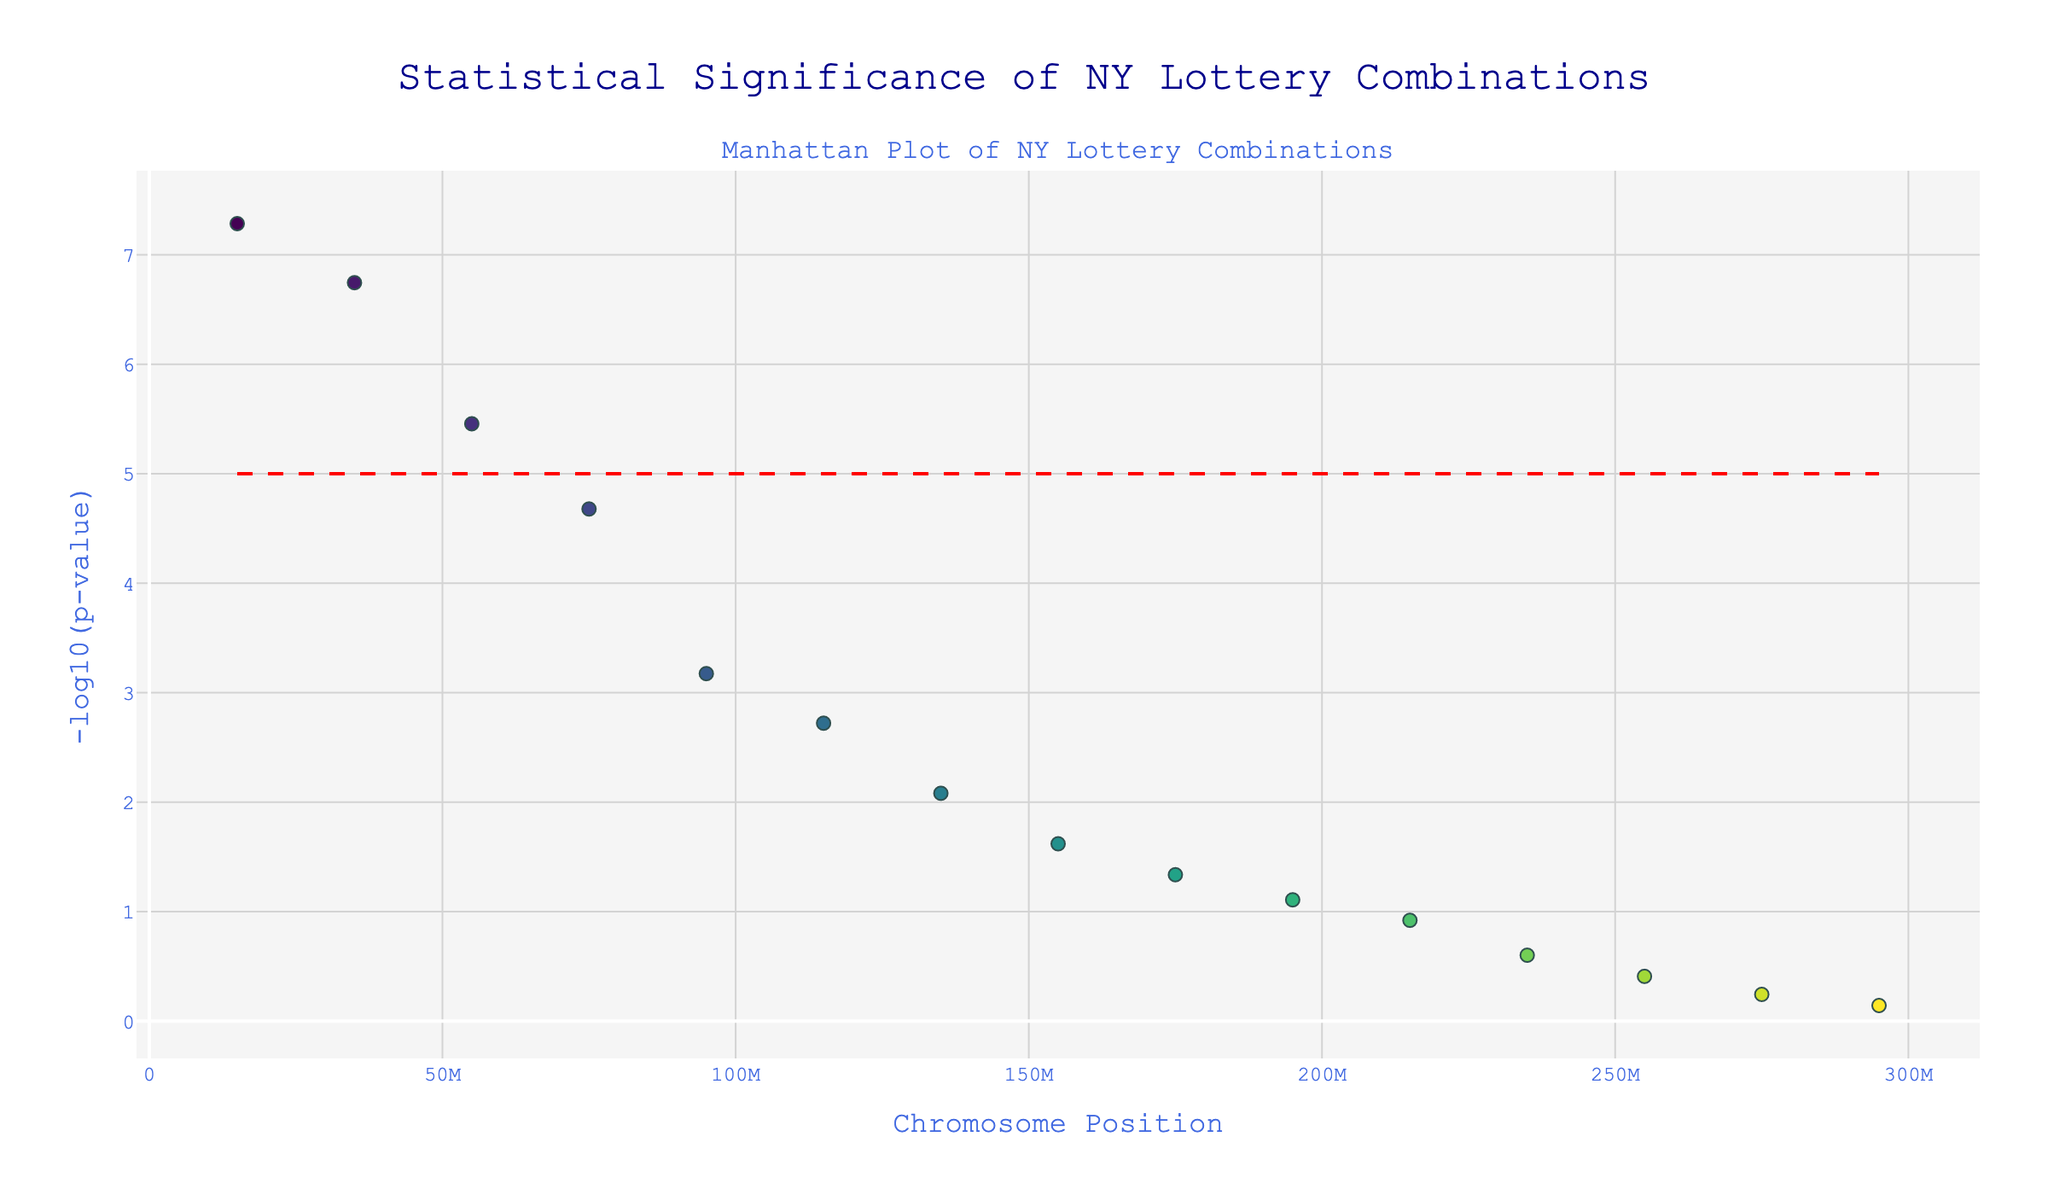what is the title of the plot? The title is found at the top of the plot, usually in a larger and distinct font size compared to other text elements. By glancing at the top, you will see that the title is "Statistical Significance of NY Lottery Combinations".
Answer: Statistical Significance of NY Lottery Combinations What do the colors of the markers represent? The colors of the markers represent different chromosomes, as indicated by the varying shades on the plot. Each color corresponds to data points from a specific chromosome based on the numbers 1 to 15.
Answer: Different chromosomes How can you identify the most statistically significant lottery combination? In a Manhattan plot, the most statistically significant combinations appear at the top of the plot because they have the highest -log10(p-value). Here, the topmost data point has a p-value of 5.2e-8 for the combination 01-17-22-33-45-56.
Answer: 01-17-22-33-45-56 What is indicated by the red dashed line on the plot? The red dashed line represents a threshold for significance. In this plot, it is drawn at y = 5, meaning any data point above this line has a -log10(p-value) greater than 5, which is considered statistically significant.
Answer: Threshold for significance How many data points are considered statistically significant according to the threshold line? By looking at the plot, count the number of points above the red dashed line. There are two points above this line: one on chromosome 1 and one on chromosome 2.
Answer: 2 Which chromosome position has the combination 15-28-39-50-61-72? To find the chromosome position for this combination, refer to the hover information or the legend in the plot. The position for the combination 15-28-39-50-61-72 is 135000000.
Answer: 135000000 What is the -log10(p-value) for the combination 09-20-31-42-53-64? Locate the combination 09-20-31-42-53-64 on the plot and note its position on the y-axis. From the list, the combination has a p-value of 2.1e-5, and its -log10(p-value) is approximately 4.68.
Answer: 4.68 Compare the statistical significance between the combinations 01-17-22-33-45-56 and 07-18-29-40-51-62. Which one is more significant? Look at the -log10(p-values) of both combinations. The combination 01-17-22-33-45-56 has a -log10(p-value) of about 7.28, while 07-18-29-40-51-62 has a -log10(p-value) of about 5.46. The higher the -log10(p-value), the more significant the combination. Therefore, 01-17-22-33-45-56 is more significant.
Answer: 01-17-22-33-45-56 What's the difference in -log10(p-value) between the combinations 03-14-25-36-47-58 and 11-23-34-45-56-67? First, find the -log10(p-values) for both combinations. For 03-14-25-36-47-58, it is approximately 6.74, and for 11-23-34-45-56-67, it is about 3.17. The difference is 6.74 - 3.17 = 3.57.
Answer: 3.57 